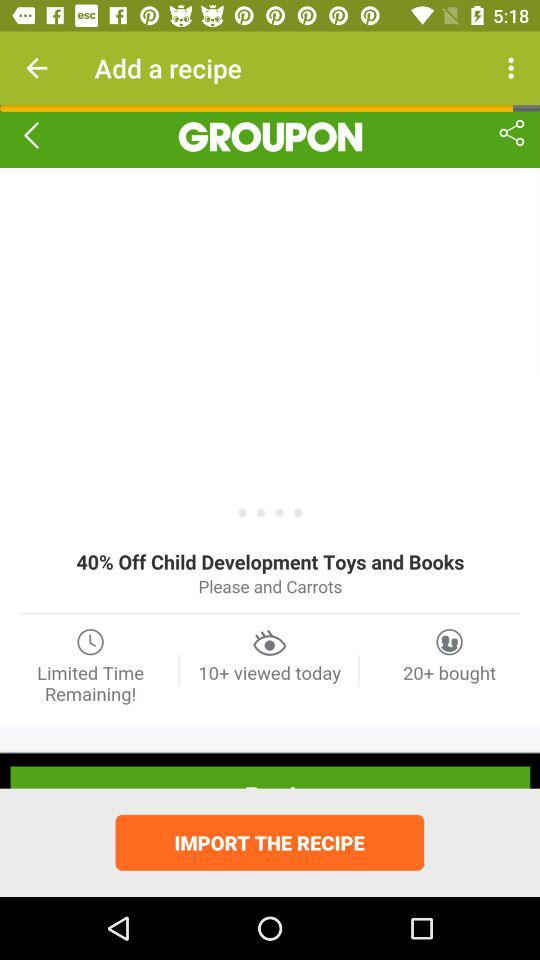How many people bought it? It was bought by 20+ people. 